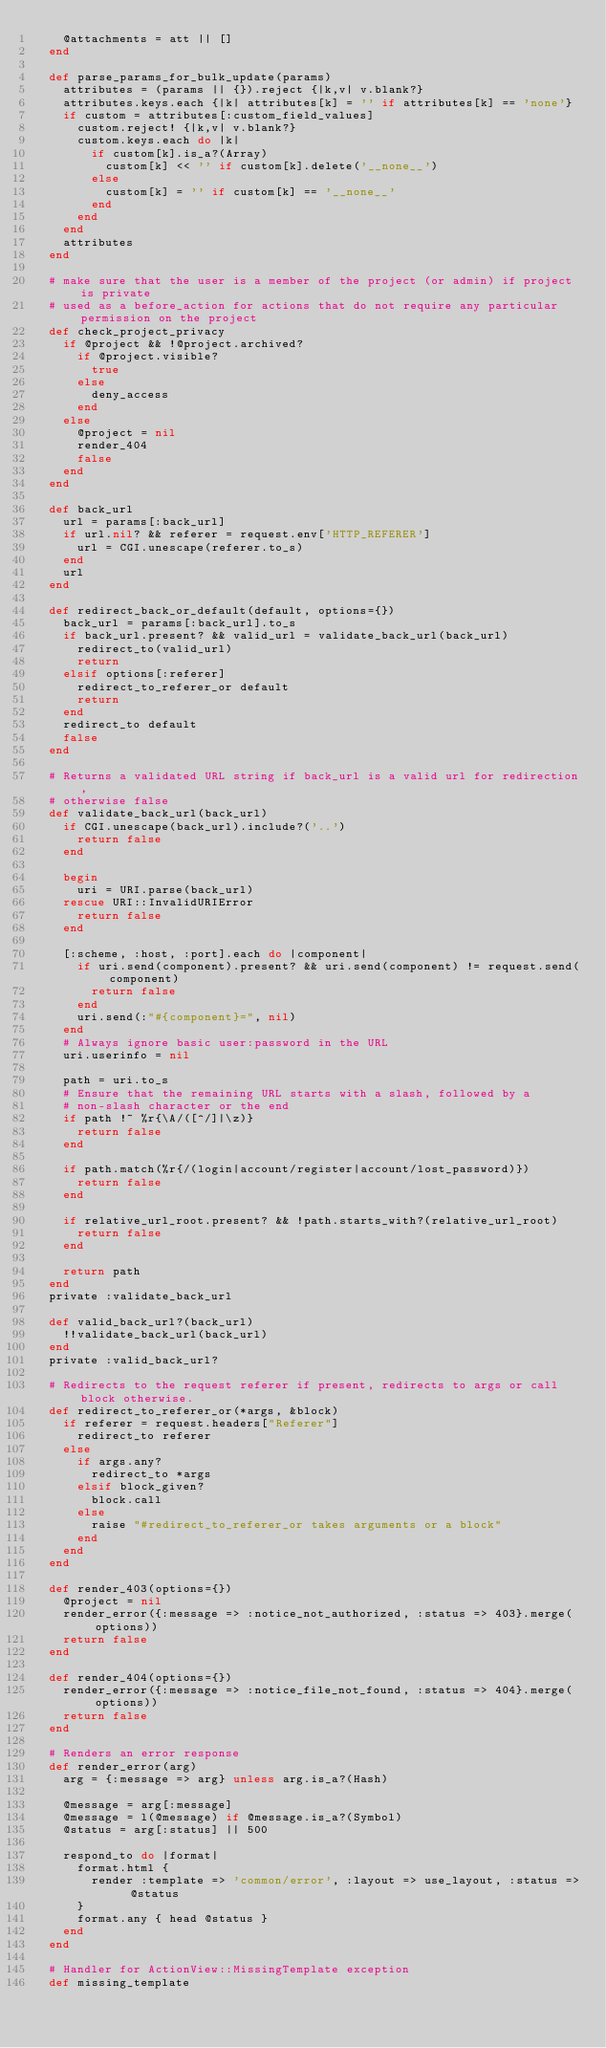<code> <loc_0><loc_0><loc_500><loc_500><_Ruby_>    @attachments = att || []
  end

  def parse_params_for_bulk_update(params)
    attributes = (params || {}).reject {|k,v| v.blank?}
    attributes.keys.each {|k| attributes[k] = '' if attributes[k] == 'none'}
    if custom = attributes[:custom_field_values]
      custom.reject! {|k,v| v.blank?}
      custom.keys.each do |k|
        if custom[k].is_a?(Array)
          custom[k] << '' if custom[k].delete('__none__')
        else
          custom[k] = '' if custom[k] == '__none__'
        end
      end
    end
    attributes
  end

  # make sure that the user is a member of the project (or admin) if project is private
  # used as a before_action for actions that do not require any particular permission on the project
  def check_project_privacy
    if @project && !@project.archived?
      if @project.visible?
        true
      else
        deny_access
      end
    else
      @project = nil
      render_404
      false
    end
  end

  def back_url
    url = params[:back_url]
    if url.nil? && referer = request.env['HTTP_REFERER']
      url = CGI.unescape(referer.to_s)
    end
    url
  end

  def redirect_back_or_default(default, options={})
    back_url = params[:back_url].to_s
    if back_url.present? && valid_url = validate_back_url(back_url)
      redirect_to(valid_url)
      return
    elsif options[:referer]
      redirect_to_referer_or default
      return
    end
    redirect_to default
    false
  end

  # Returns a validated URL string if back_url is a valid url for redirection,
  # otherwise false
  def validate_back_url(back_url)
    if CGI.unescape(back_url).include?('..')
      return false
    end

    begin
      uri = URI.parse(back_url)
    rescue URI::InvalidURIError
      return false
    end

    [:scheme, :host, :port].each do |component|
      if uri.send(component).present? && uri.send(component) != request.send(component)
        return false
      end
      uri.send(:"#{component}=", nil)
    end
    # Always ignore basic user:password in the URL
    uri.userinfo = nil

    path = uri.to_s
    # Ensure that the remaining URL starts with a slash, followed by a
    # non-slash character or the end
    if path !~ %r{\A/([^/]|\z)}
      return false
    end

    if path.match(%r{/(login|account/register|account/lost_password)})
      return false
    end

    if relative_url_root.present? && !path.starts_with?(relative_url_root)
      return false
    end

    return path
  end
  private :validate_back_url

  def valid_back_url?(back_url)
    !!validate_back_url(back_url)
  end
  private :valid_back_url?

  # Redirects to the request referer if present, redirects to args or call block otherwise.
  def redirect_to_referer_or(*args, &block)
    if referer = request.headers["Referer"]
      redirect_to referer
    else
      if args.any?
        redirect_to *args
      elsif block_given?
        block.call
      else
        raise "#redirect_to_referer_or takes arguments or a block"
      end
    end
  end

  def render_403(options={})
    @project = nil
    render_error({:message => :notice_not_authorized, :status => 403}.merge(options))
    return false
  end

  def render_404(options={})
    render_error({:message => :notice_file_not_found, :status => 404}.merge(options))
    return false
  end

  # Renders an error response
  def render_error(arg)
    arg = {:message => arg} unless arg.is_a?(Hash)

    @message = arg[:message]
    @message = l(@message) if @message.is_a?(Symbol)
    @status = arg[:status] || 500

    respond_to do |format|
      format.html {
        render :template => 'common/error', :layout => use_layout, :status => @status
      }
      format.any { head @status }
    end
  end

  # Handler for ActionView::MissingTemplate exception
  def missing_template</code> 